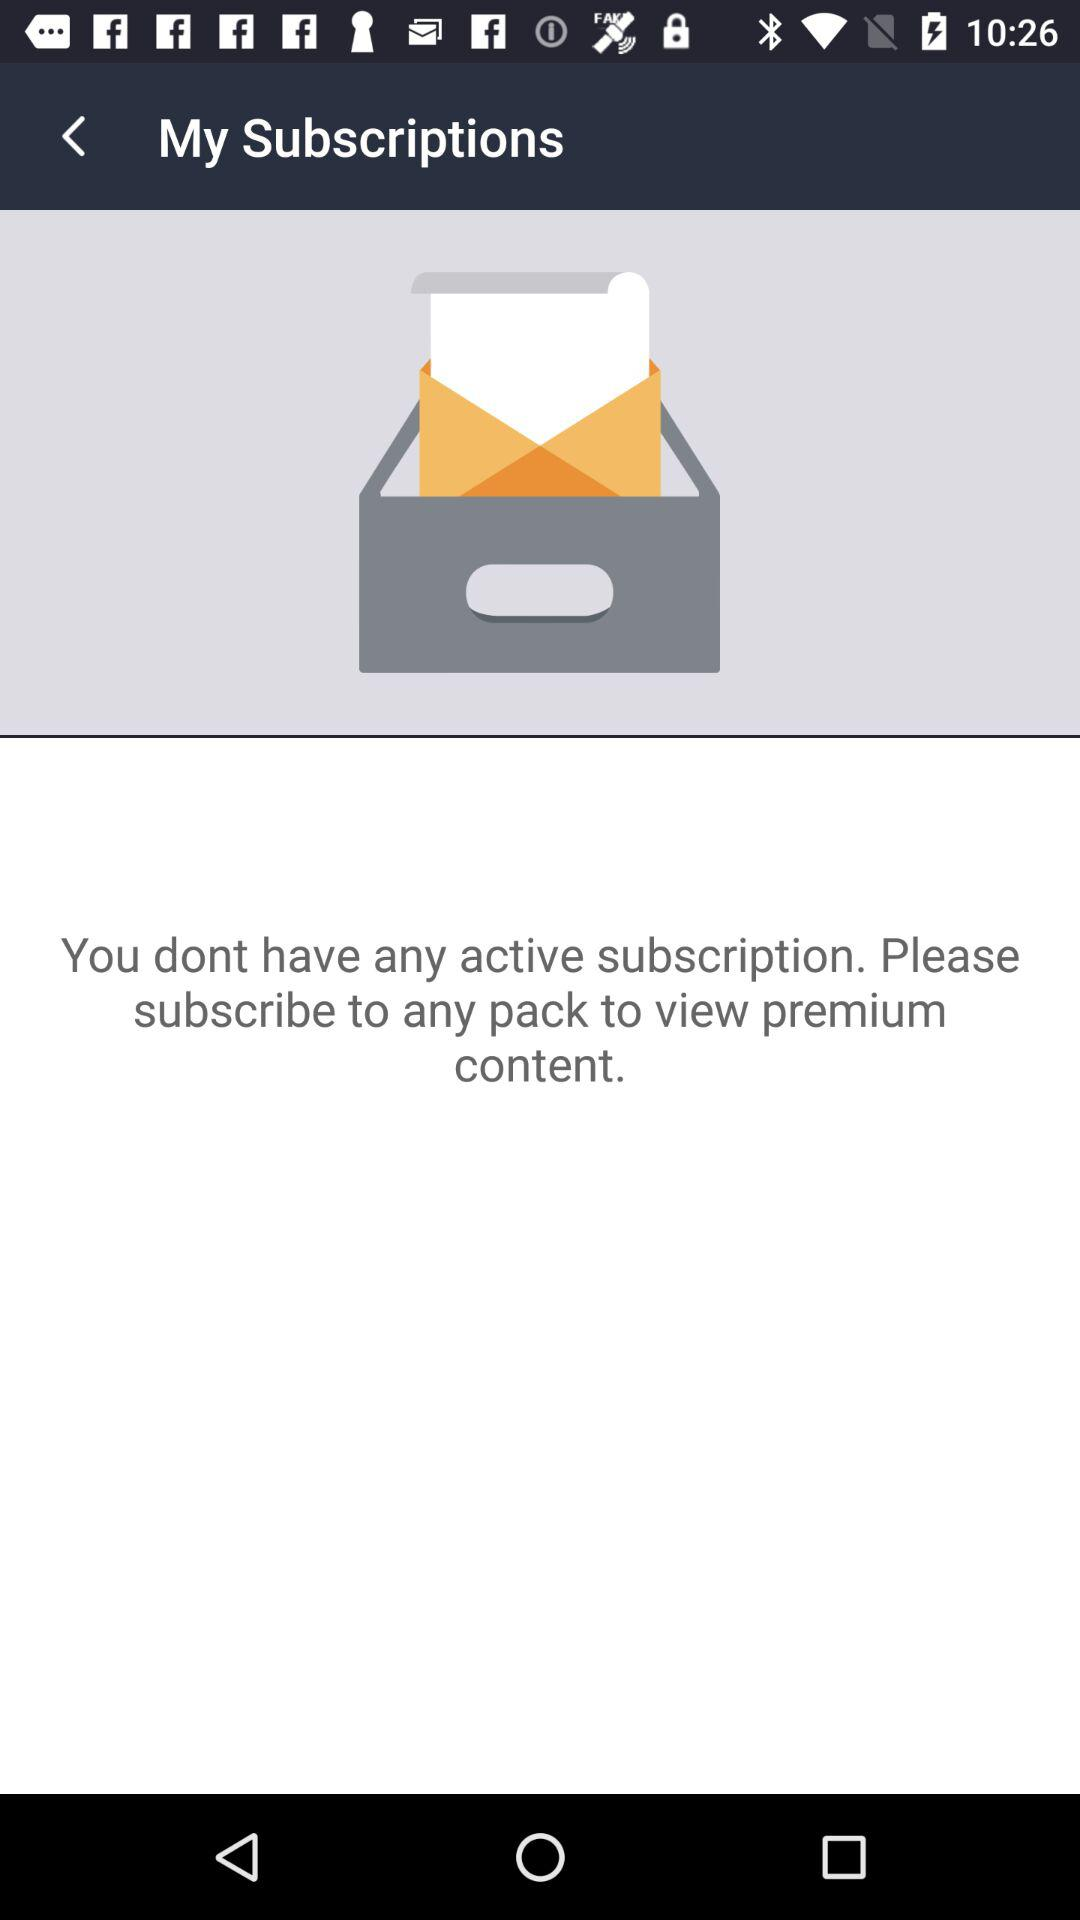Can you tell me what the icons at the top of the screen indicate? The icons at the top of the screen represent common social media and connectivity features. From left to right, they typically stand for social media notifications, Wi-Fi connectivity strength, and battery level. These icons may allow you to quickly access notifications or settings related to these features. 